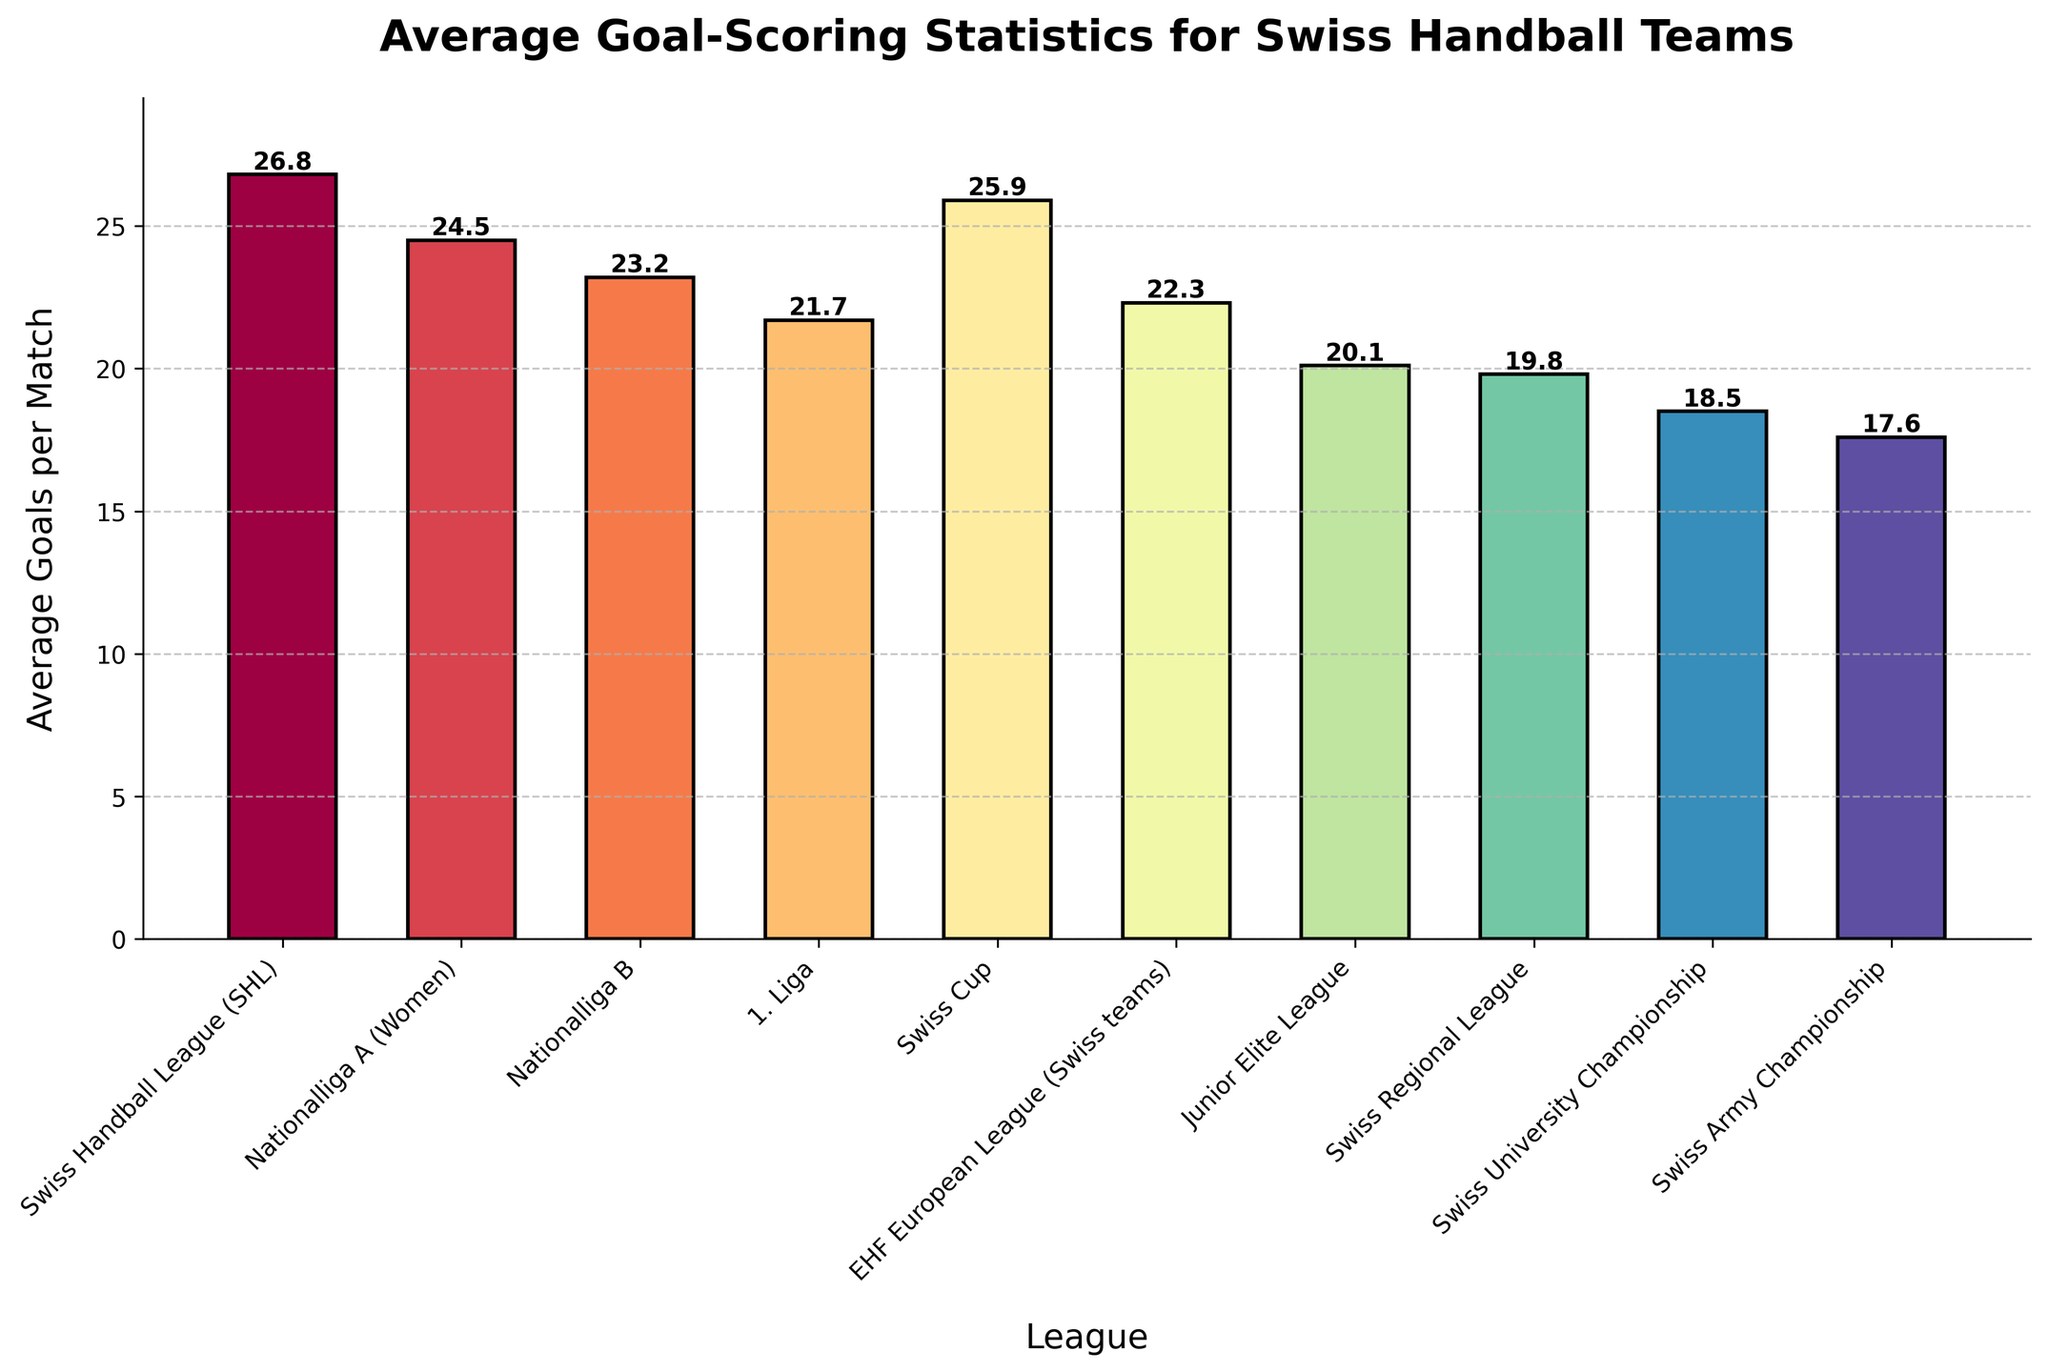Which league has the highest average goals per match? Look for the tallest bar in the chart, which represents the league with the highest average goals.
Answer: Swiss Handball League (SHL) Which league has the lowest average goals per match? Identify the shortest bar in the chart, which represents the league with the lowest average goals.
Answer: Swiss Army Championship How many leagues have an average of more than 25 goals per match? Count the number of bars that exceed the 25 goals per match mark on the y-axis.
Answer: 3 What is the difference in average goals per match between the Swiss Handball League (SHL) and the Swiss Army Championship? Subtract the value for the Swiss Army Championship from the value for the Swiss Handball League (SHL): 26.8 - 17.6.
Answer: 9.2 Which league has a higher average goals per match, the Swiss Cup or Nationalliga B? Compare the heights of the bars for the Swiss Cup and Nationalliga B.
Answer: Swiss Cup How much higher is the average goals per match in the EHF European League (Swiss teams) compared to the Swiss University Championship? Subtract the value for the Swiss University Championship from the value for the EHF European League (Swiss teams): 22.3 - 18.5.
Answer: 3.8 What is the range of average goals per match across all leagues? Find the difference between the highest and lowest values: 26.8 - 17.6.
Answer: 9.2 Do any leagues have an average goals per match between 20 and 22? Check if any bars fall within the range of 20 to 22 goals per match.
Answer: Yes, Junior Elite League and EHF European League (Swiss teams) Is the average goal-scoring in Nationalliga A (Women) higher or lower than the Swiss Regional League? Compare the heights of the bars for Nationalliga A (Women) and Swiss Regional League.
Answer: Higher What is the approximate median value of the average goals per match across all leagues? Arrange the data points in ascending order and find the middle value (or average of the two middle values if even number of data points): 17.6, 18.5, 19.8, 20.1, 21.7, 22.3, 23.2, 24.5, 25.9, 26.8. The median is the average of the 5th and 6th values: (21.7 + 22.3)/2.
Answer: 22.0 